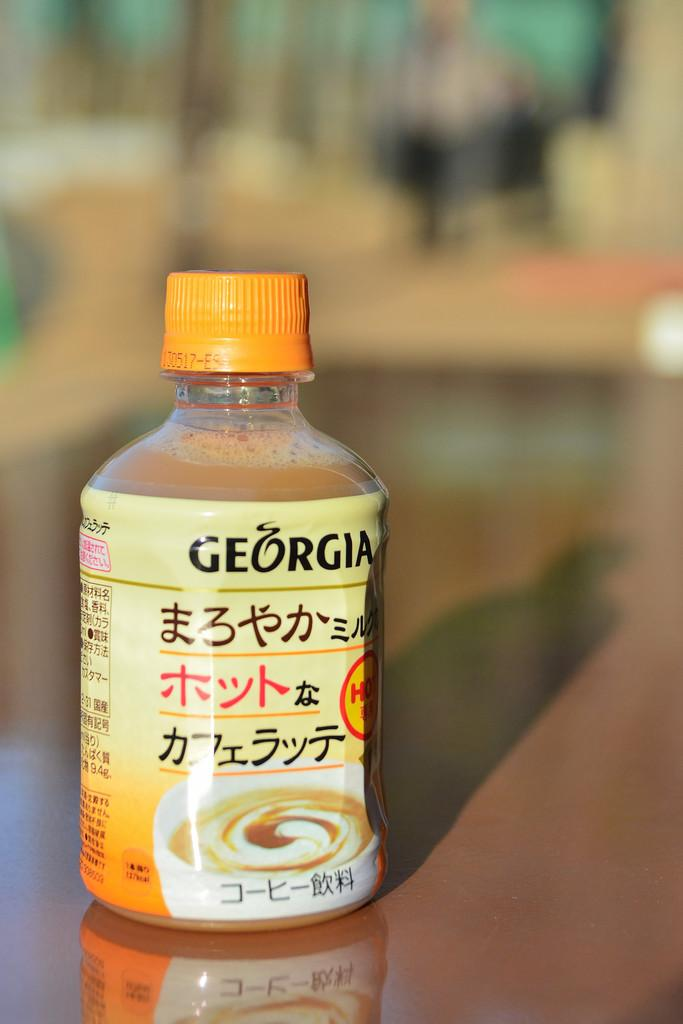<image>
Present a compact description of the photo's key features. A bottle of Georgia sauce rests on a tabletop. 